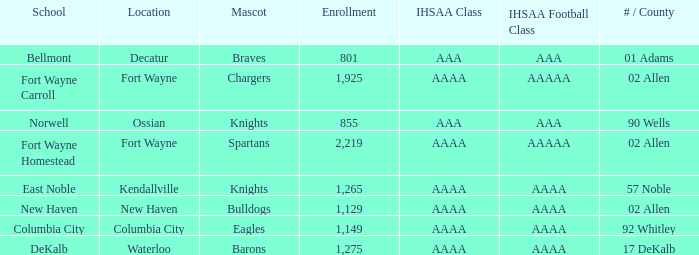What school has a mascot of the spartans with an AAAA IHSAA class and more than 1,275 enrolled? Fort Wayne Homestead. 